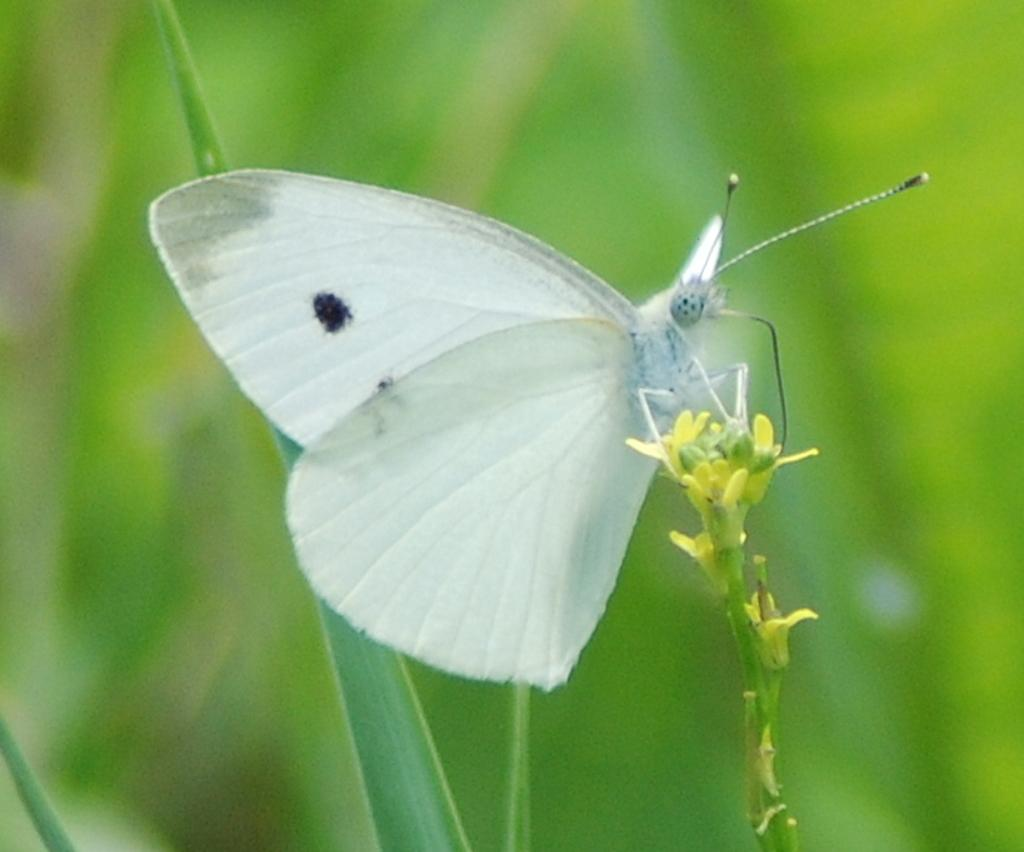What is the main subject in the foreground of the image? There is a butterfly on a plant in the foreground of the image. What can be seen in the background of the image? There are plants visible in the background of the image. What type of suggestion does the lawyer make in the image? There is no lawyer present in the image, and therefore no suggestion can be made. 